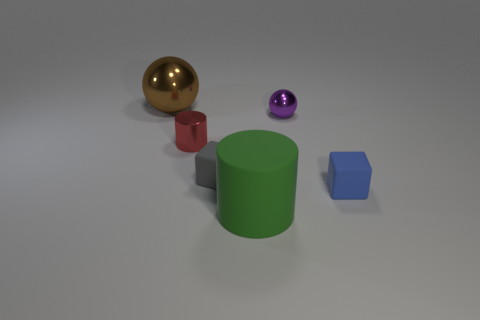Add 1 cylinders. How many objects exist? 7 Subtract all blocks. How many objects are left? 4 Subtract 0 purple cylinders. How many objects are left? 6 Subtract all large brown objects. Subtract all small red shiny objects. How many objects are left? 4 Add 1 large brown spheres. How many large brown spheres are left? 2 Add 6 tiny metallic balls. How many tiny metallic balls exist? 7 